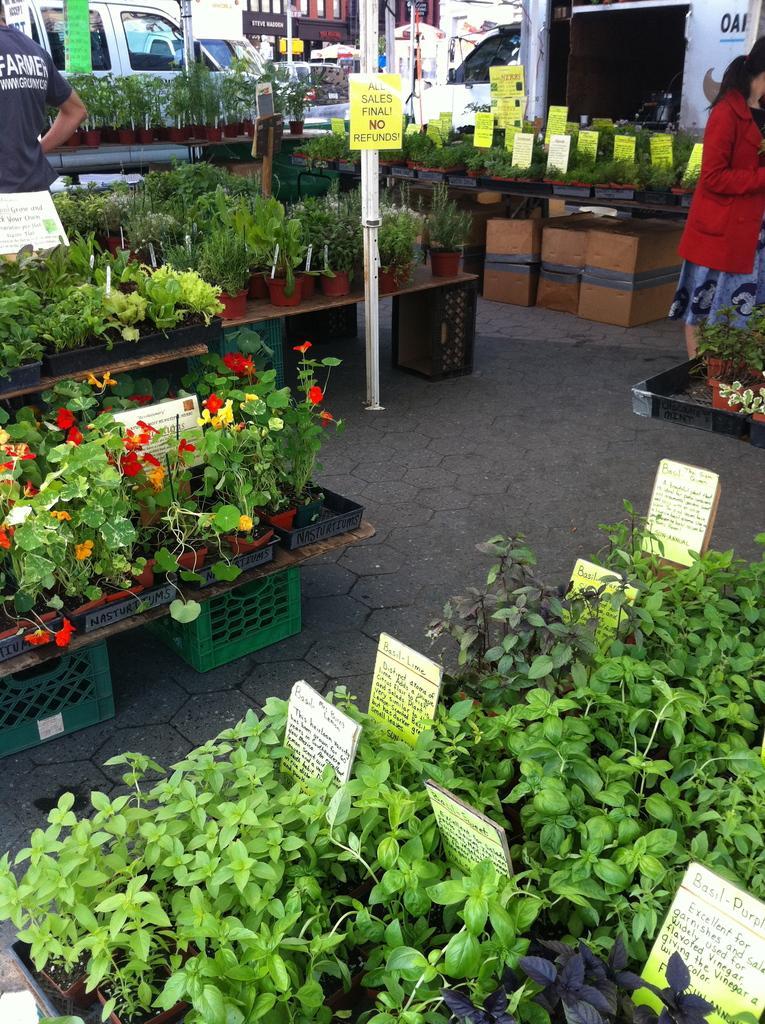Can you describe this image briefly? In the picture I can see few plants which are placed on an object and there is something written in between it and there is a woman standing in the right corner and there are few vehicles and buildings in the background. 